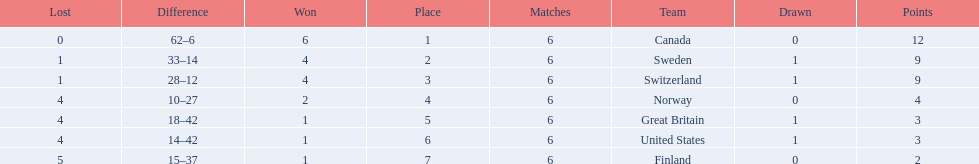What are the names of the countries? Canada, Sweden, Switzerland, Norway, Great Britain, United States, Finland. How many wins did switzerland have? 4. How many wins did great britain have? 1. Which country had more wins, great britain or switzerland? Switzerland. 